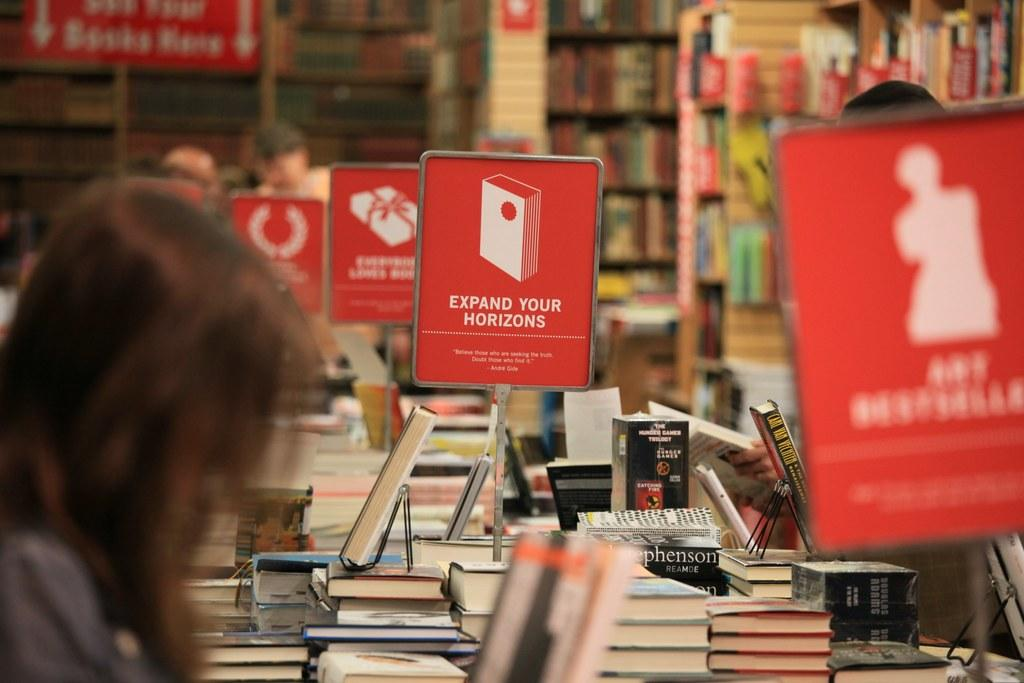<image>
Render a clear and concise summary of the photo. People are browsing a table of books with a sign that says Expand Your Horizons. 